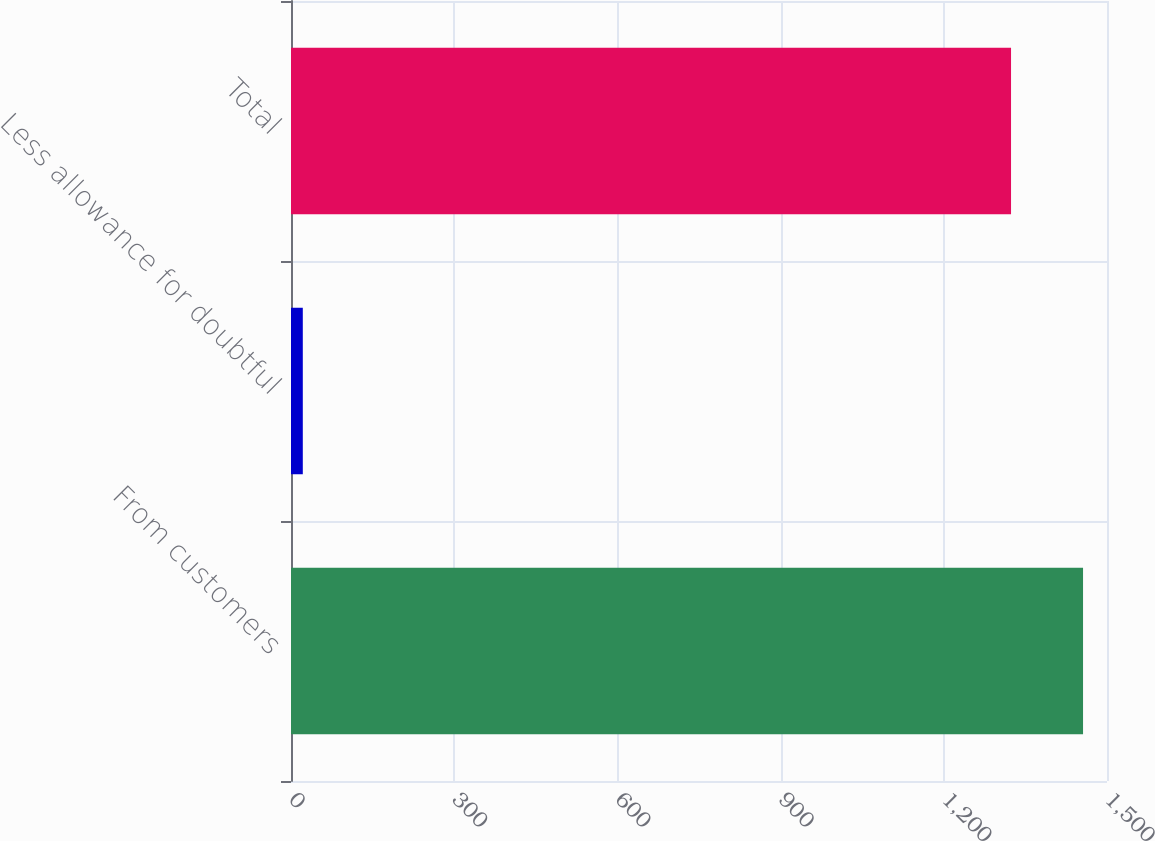<chart> <loc_0><loc_0><loc_500><loc_500><bar_chart><fcel>From customers<fcel>Less allowance for doubtful<fcel>Total<nl><fcel>1455.96<fcel>21.7<fcel>1323.6<nl></chart> 